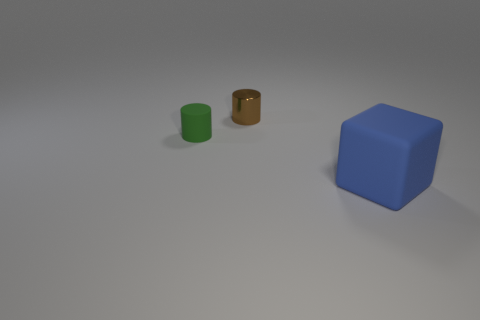Is there another matte thing of the same shape as the brown thing?
Give a very brief answer. Yes. How many things are either objects behind the blue matte block or rubber things?
Offer a very short reply. 3. What number of gray things are either cylinders or rubber things?
Your answer should be compact. 0. Is the number of big blue things on the left side of the small green cylinder less than the number of blue matte things?
Make the answer very short. Yes. What color is the small cylinder on the right side of the cylinder in front of the tiny brown object that is behind the tiny matte thing?
Your response must be concise. Brown. Is there anything else that has the same material as the tiny brown thing?
Your answer should be compact. No. There is another thing that is the same shape as the metallic object; what is its size?
Keep it short and to the point. Small. Are there fewer metal objects to the right of the brown cylinder than big things that are on the left side of the matte cube?
Your answer should be very brief. No. What is the shape of the thing that is to the right of the green matte cylinder and left of the big object?
Provide a short and direct response. Cylinder. What size is the cylinder that is made of the same material as the blue thing?
Make the answer very short. Small. 